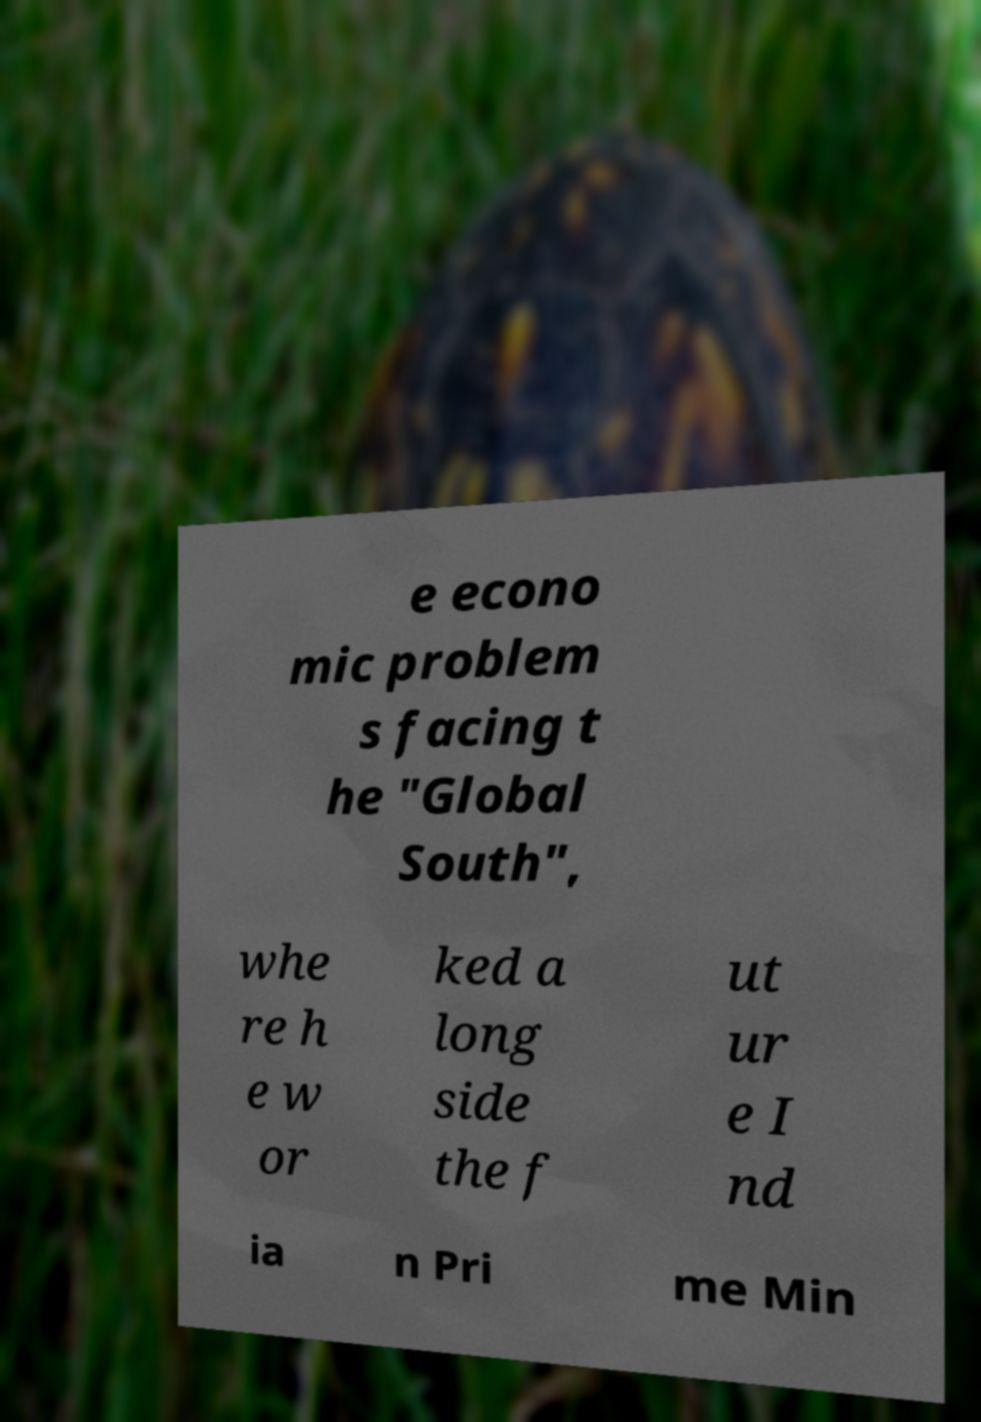Can you read and provide the text displayed in the image?This photo seems to have some interesting text. Can you extract and type it out for me? e econo mic problem s facing t he "Global South", whe re h e w or ked a long side the f ut ur e I nd ia n Pri me Min 